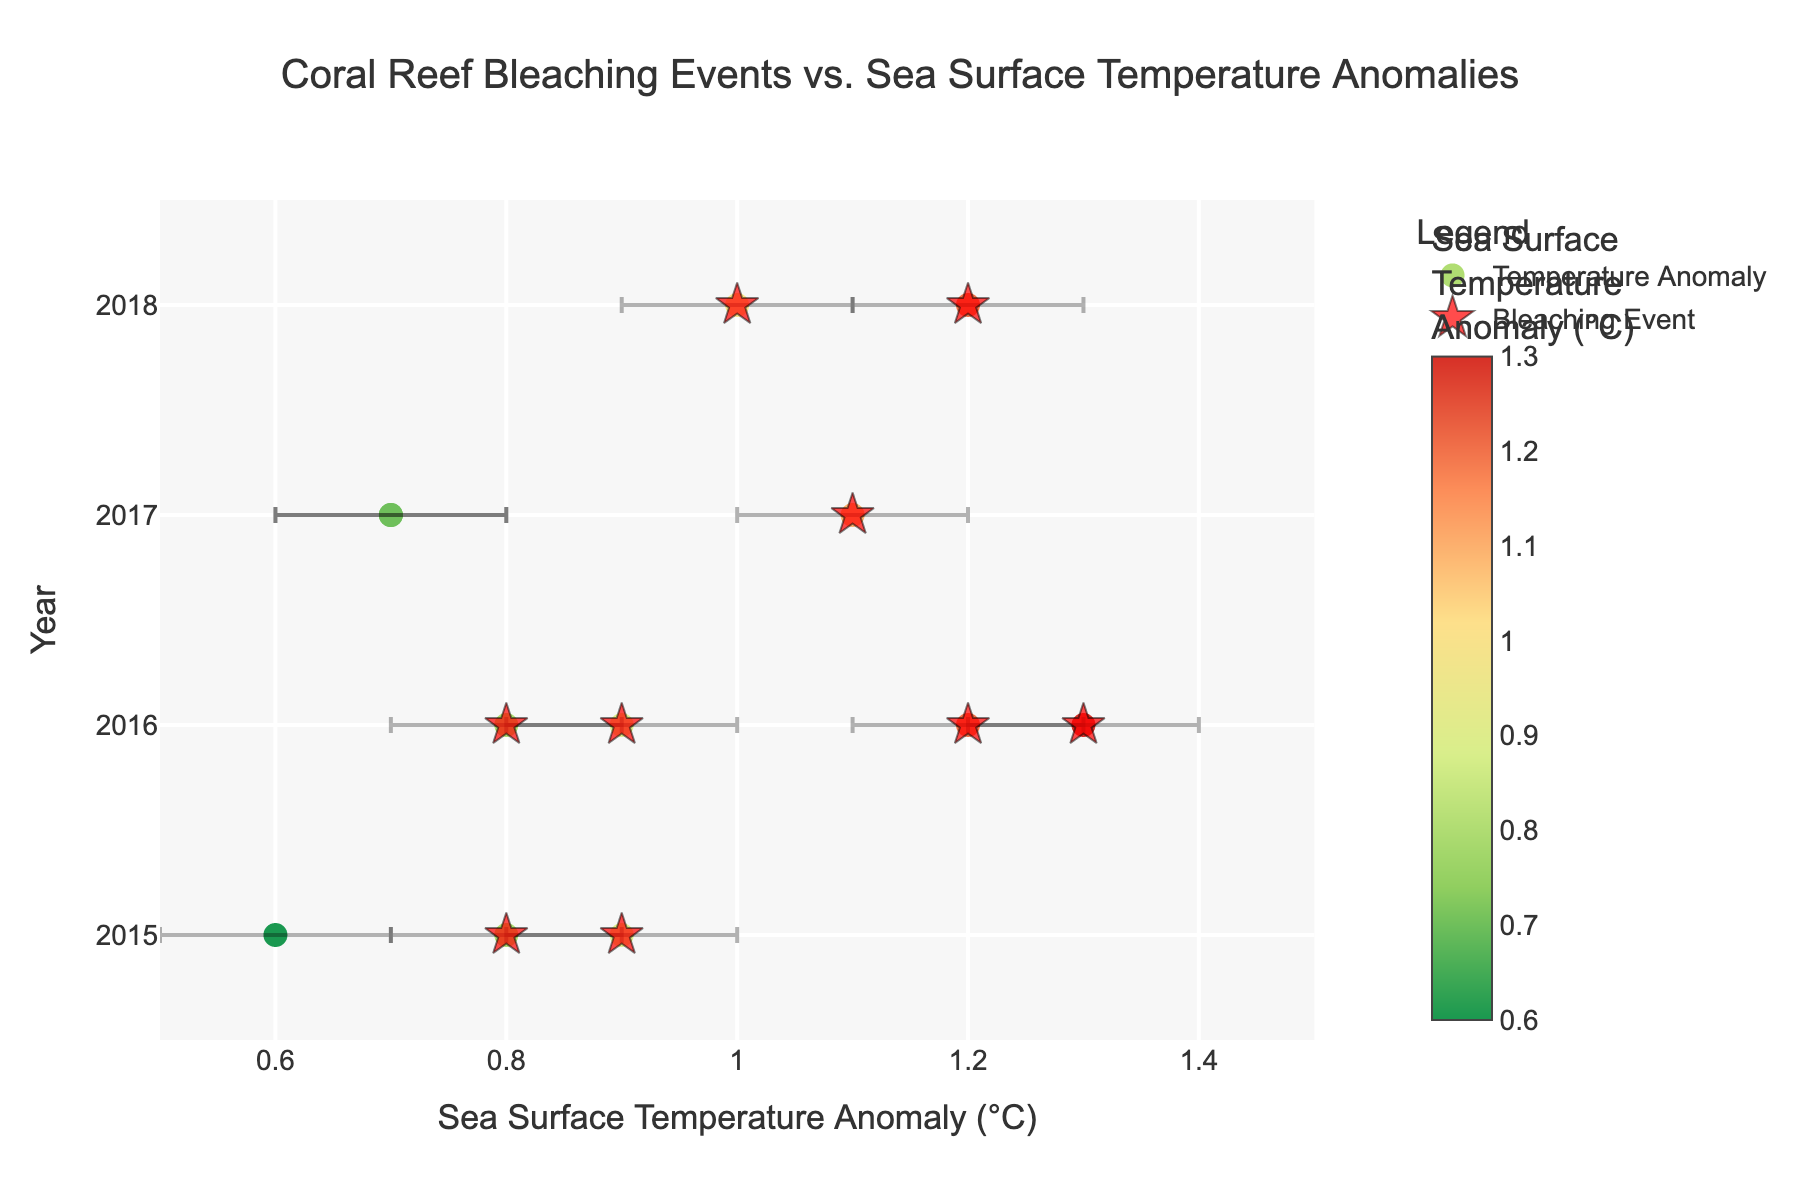What is the title of the plot? The title of the plot is displayed prominently at the top of the figure.
Answer: Coral Reef Bleaching Events vs. Sea Surface Temperature Anomalies What years are shown on the y-axis? The y-axis of the plot lists the range of years included in the data.
Answer: 2015 to 2018 How are bleaching events visually represented in the plot? Bleaching events are indicated using a distinct marker style, often highlighted to attract attention.
Answer: Red star symbol What is the color gradient indicating in the scatter plot? The color gradient is used to encode the sea surface temperature anomalies with different shades showing different values.
Answer: Sea Surface Temperature Anomaly (°C) What is the average sea surface temperature anomaly for the bleaching events in 2016? Sum the sea surface temperature anomalies for 2016 where bleaching events occurred and divide by the number of those events. There are three regions (Philippines, Malaysia, and Solomon Islands) with anomalies 1.2, 1.3, and 0.8 respectively. The calculation is (1.2 + 1.3 + 0.8) / 3.
Answer: 1.1 What is the difference between the highest and lowest sea surface temperature anomaly recorded in this plot? Identify the maximum and minimum values from the sea surface temperature anomalies. Maximum is 1.3 (Malaysia, 2016) and minimum is 0.6 (Papua New Guinea, 2015). The difference is 1.3 - 0.6.
Answer: 0.7 Which region had the highest sea surface temperature anomaly in 2015? From the 2015 data points, compare the temperature anomalies recorded. The Philippines had 0.8 and Malaysia had 0.9.
Answer: Malaysia How many bleaching events occurred in 2017? Count the number of distinct markers (red stars) indicating bleaching events specifically in 2017. There are two (Indonesia and Solomon Islands).
Answer: 2 What does the black vertical bar on each data point represent? The black vertical bars symbolize the confidence interval for each sea surface temperature anomaly, indicating the range of uncertainty.
Answer: Confidence Interval Which region shows no bleaching event despite a high sea surface temperature anomaly in 2017? Locate the year 2017 and observe regions with high temperature anomalies but no bleaching star symbol. Indonesia has a temperature anomaly of 0.7 but no bleaching event.
Answer: Indonesia 